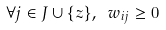<formula> <loc_0><loc_0><loc_500><loc_500>\forall j \in J \cup \{ z \} , \ w _ { i j } \geq 0</formula> 